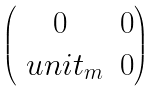Convert formula to latex. <formula><loc_0><loc_0><loc_500><loc_500>\begin{pmatrix} 0 & 0 \\ \ u n i t _ { m } & 0 \end{pmatrix}</formula> 